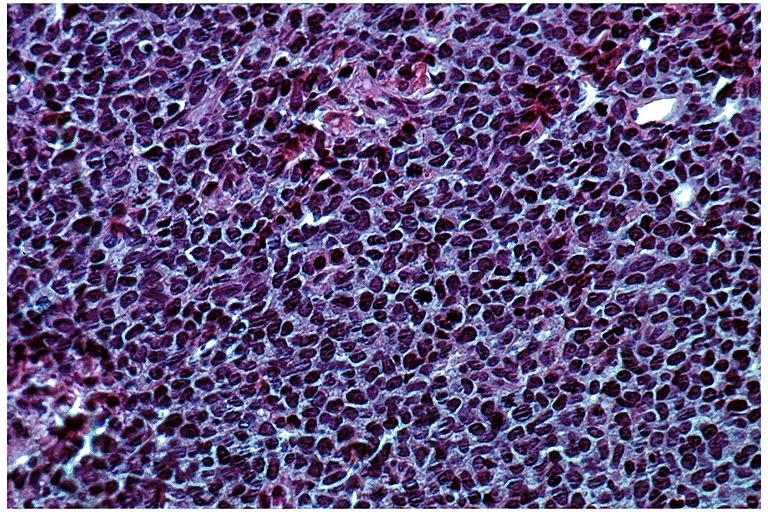s oral present?
Answer the question using a single word or phrase. Yes 